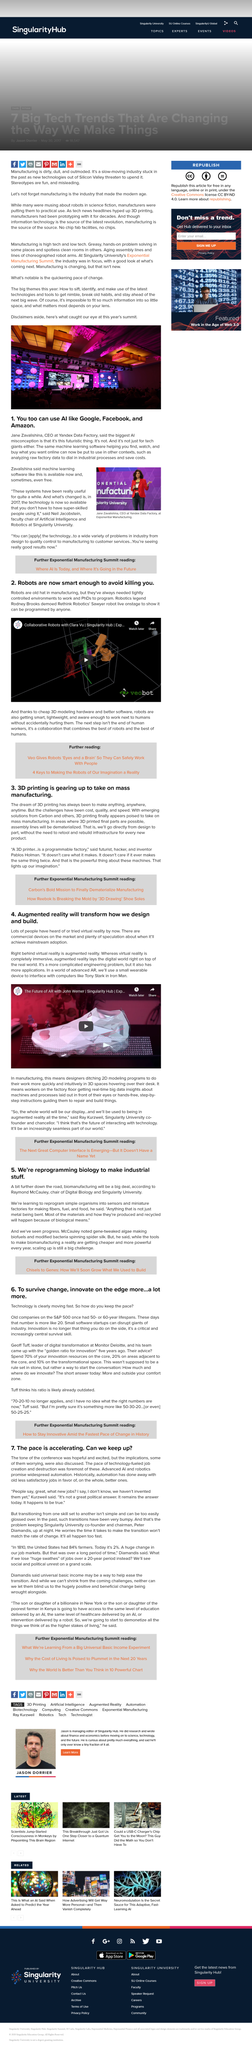Specify some key components in this picture. It has been suggested that the process of reprogramming simple organisms involves transforming them into sensors and miniature factories capable of producing fibers, fuel, and food, as well as potentially bending other materials besides metal. The Rethink Robotics' Sawyer robot is capable of being programmed by individuals without requiring tight control, demonstrating that robots can function effectively with more flexible programming. Approximately 10% of an organization's innovations should be allocated towards transformational spaces. Yes, some AI is free. Raymond McCauley is the chair of Digital Biology and Singularity University. 